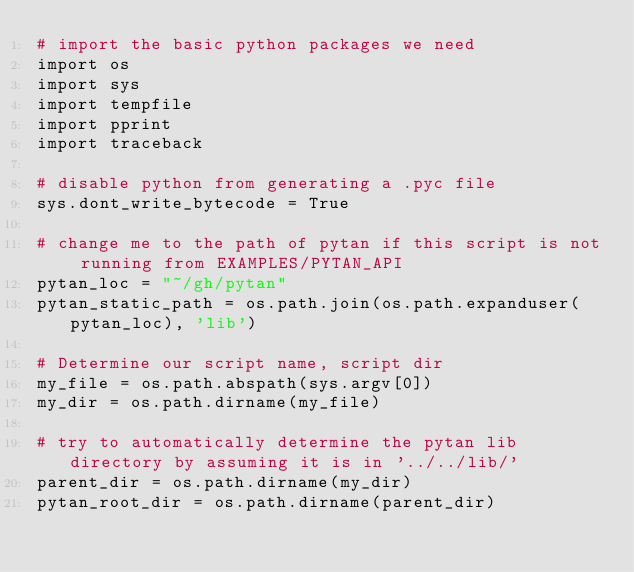Convert code to text. <code><loc_0><loc_0><loc_500><loc_500><_Python_># import the basic python packages we need
import os
import sys
import tempfile
import pprint
import traceback

# disable python from generating a .pyc file
sys.dont_write_bytecode = True

# change me to the path of pytan if this script is not running from EXAMPLES/PYTAN_API
pytan_loc = "~/gh/pytan"
pytan_static_path = os.path.join(os.path.expanduser(pytan_loc), 'lib')

# Determine our script name, script dir
my_file = os.path.abspath(sys.argv[0])
my_dir = os.path.dirname(my_file)

# try to automatically determine the pytan lib directory by assuming it is in '../../lib/'
parent_dir = os.path.dirname(my_dir)
pytan_root_dir = os.path.dirname(parent_dir)</code> 